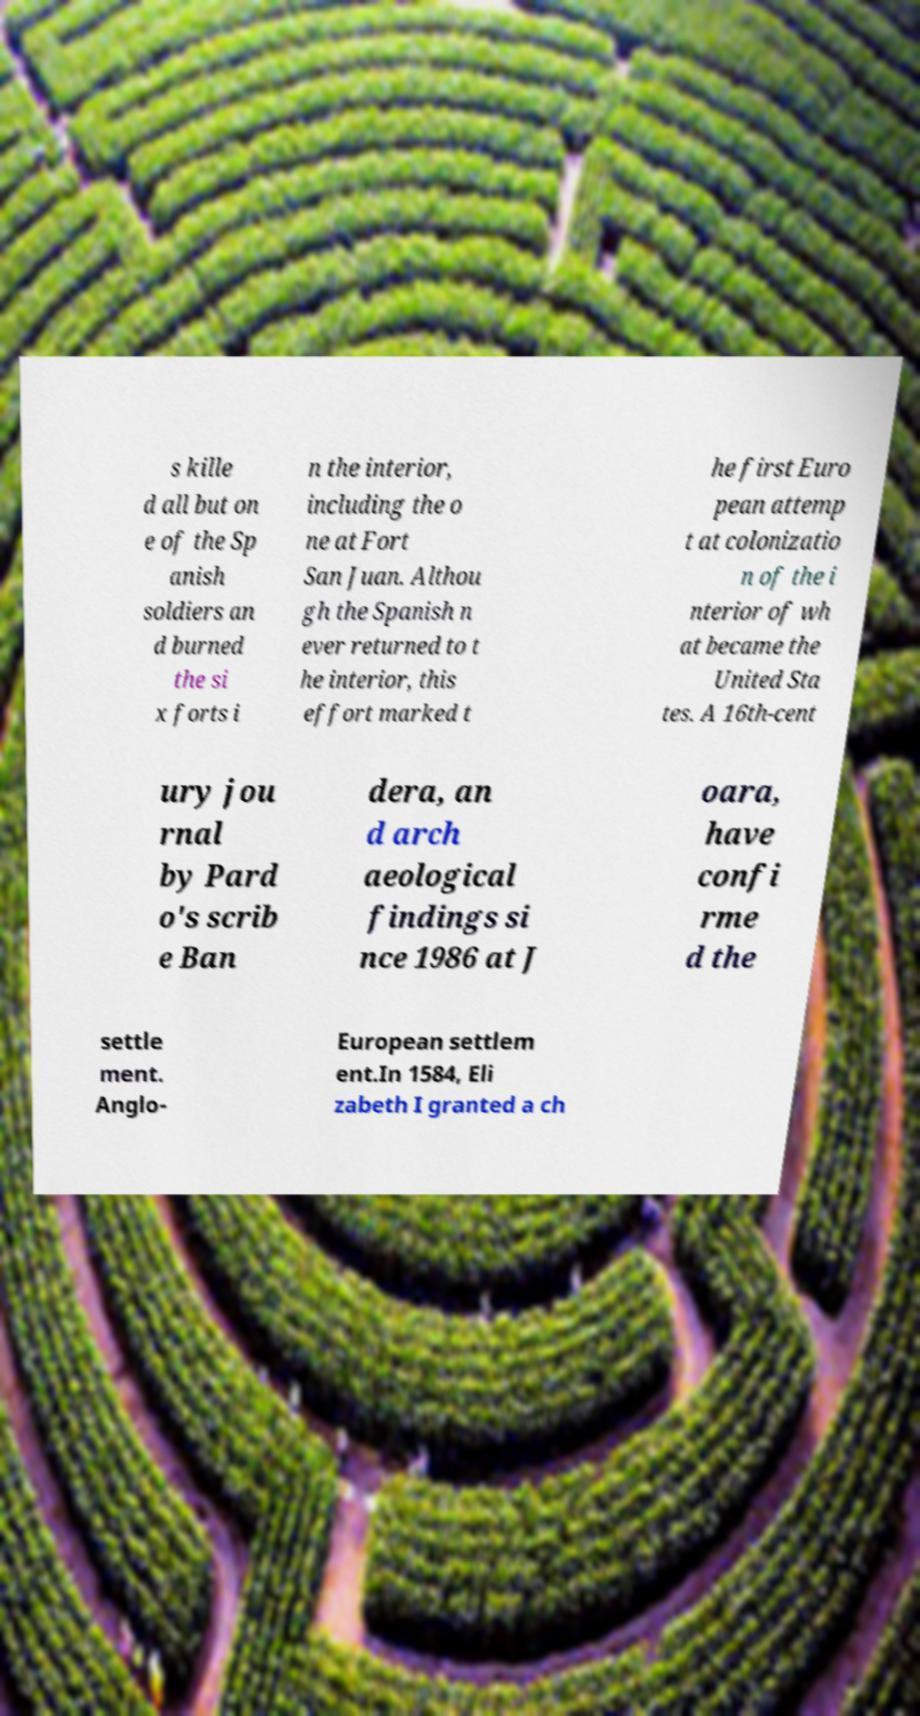There's text embedded in this image that I need extracted. Can you transcribe it verbatim? s kille d all but on e of the Sp anish soldiers an d burned the si x forts i n the interior, including the o ne at Fort San Juan. Althou gh the Spanish n ever returned to t he interior, this effort marked t he first Euro pean attemp t at colonizatio n of the i nterior of wh at became the United Sta tes. A 16th-cent ury jou rnal by Pard o's scrib e Ban dera, an d arch aeological findings si nce 1986 at J oara, have confi rme d the settle ment. Anglo- European settlem ent.In 1584, Eli zabeth I granted a ch 